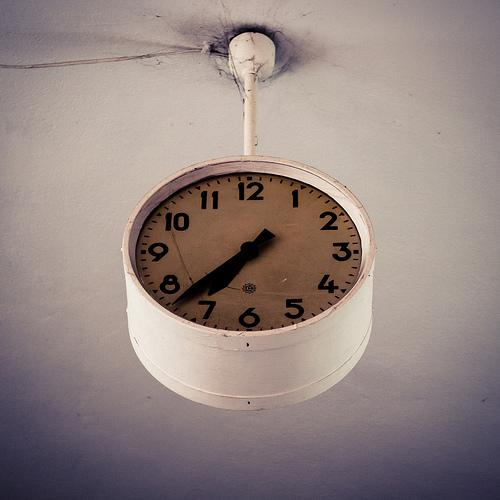Which number has the smallest image in terms of width and height? Number two has the smallest image with a width of 23 and height of 23. Can you identify a specific number on the clock that is mentioned repeatedly? The number five is mentioned several times in different positions and sizes. How would you describe the appearance of the clock in the image? It is a round white clock with black numbers and hands. What is the primary object in this image? A white clock hanging from the ceiling. What task would you perform if you were to identify irregularities or unusual elements in the image? I would perform the image anomaly detection task. Does the clock have any distinctive characteristics? The clock has black numbers and hands, as well as a round face. What is the task aimed at understanding the context or relationships between objects in the image? The image context analysis task focuses on understanding the relationships and context between objects. In which task do we need to analyze the emotional impact or feeling elicited by the image's content? The image sentiment analysis task involves evaluating the emotional impact or feelings evoked by the image's content. What is the main purpose of the image specified in the given data? The image serve to localize and highlight specific elements or features within the image for various tasks. What color are the numbers on the clock in the image? The numbers on the clock are black. Is there a digital clock in the image? No, it's not mentioned in the image. Can you see a white number six on the clock? The information about the number six in the image is mentioned as black (number six in black). Introducing a white number six makes the instruction misleading. Does the clock have roman numerals instead of numbers? The image information describes several numbers on the clock as regular numerals (number one, number two, etc.). By asking about roman numerals, the instruction becomes misleading. Are the clock hands of different colors, like blue and green? The image mentions a white clock with black hands. By introducing different colors for the hands, such as blue and green, the instruction becomes misleading. Is the number three on the clock colored red? In the image information, the number three is mentioned as black (a black number 3). Introducing a different color, such as red, creates a misleading instruction. 